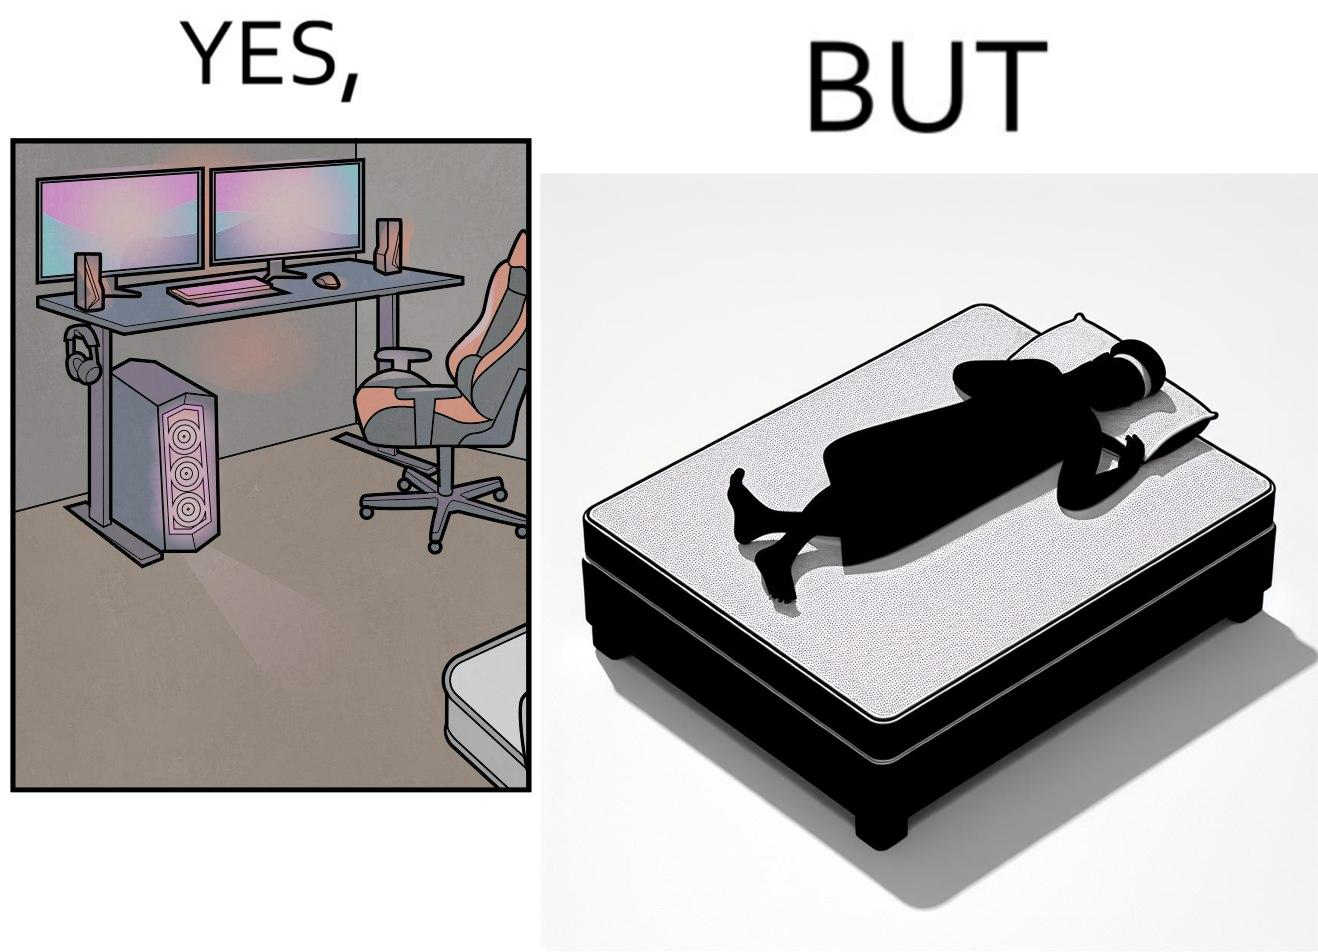Describe the satirical element in this image. The image is funny because the person has a lot of furniture for his computer but none for himself. 